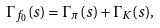Convert formula to latex. <formula><loc_0><loc_0><loc_500><loc_500>\Gamma _ { f _ { 0 } } ( s ) = \Gamma _ { \pi } ( s ) + \Gamma _ { K } ( s ) ,</formula> 